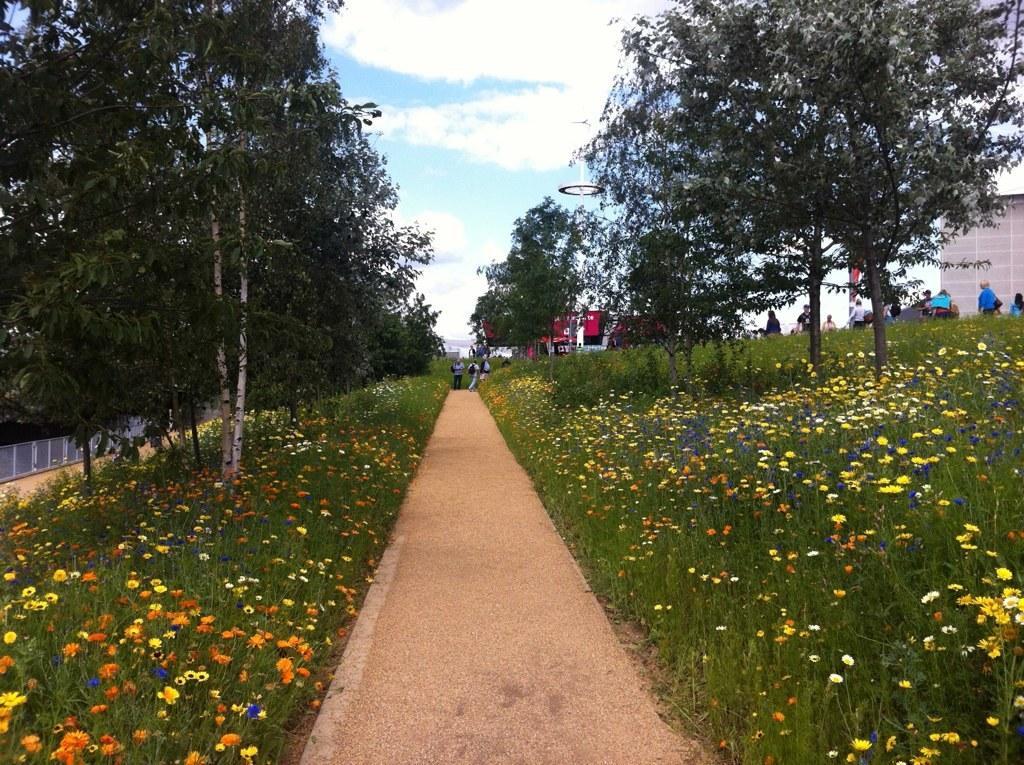Can you describe this image briefly? In the image there is a path in the middle with flower plants on either side of it with trees and above its sky with clouds. 